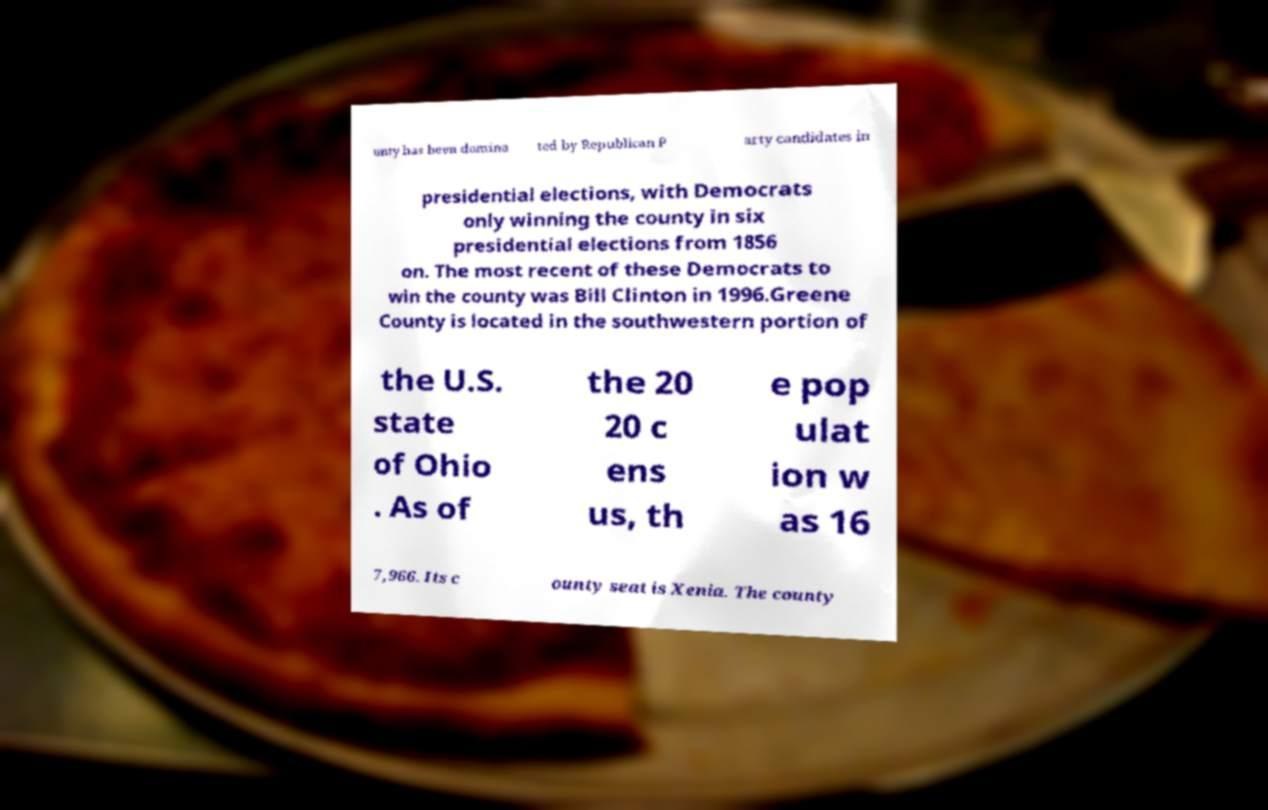What messages or text are displayed in this image? I need them in a readable, typed format. unty has been domina ted by Republican P arty candidates in presidential elections, with Democrats only winning the county in six presidential elections from 1856 on. The most recent of these Democrats to win the county was Bill Clinton in 1996.Greene County is located in the southwestern portion of the U.S. state of Ohio . As of the 20 20 c ens us, th e pop ulat ion w as 16 7,966. Its c ounty seat is Xenia. The county 